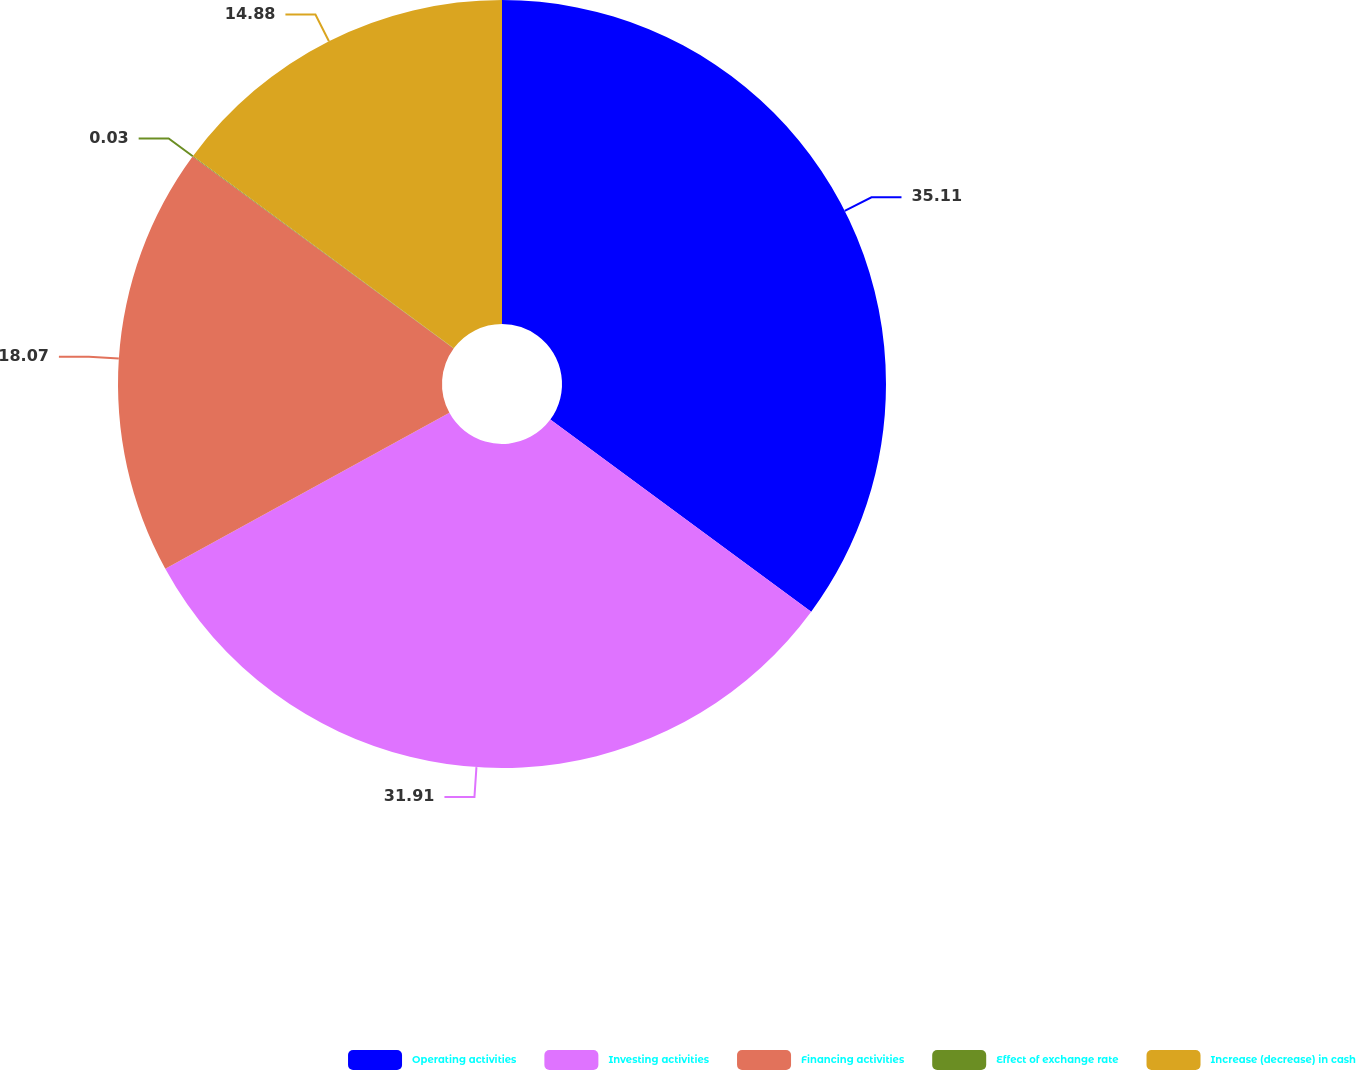Convert chart. <chart><loc_0><loc_0><loc_500><loc_500><pie_chart><fcel>Operating activities<fcel>Investing activities<fcel>Financing activities<fcel>Effect of exchange rate<fcel>Increase (decrease) in cash<nl><fcel>35.1%<fcel>31.91%<fcel>18.07%<fcel>0.03%<fcel>14.88%<nl></chart> 